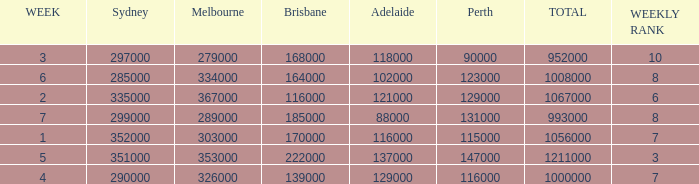How many episodes aired in Sydney in Week 3? 1.0. 